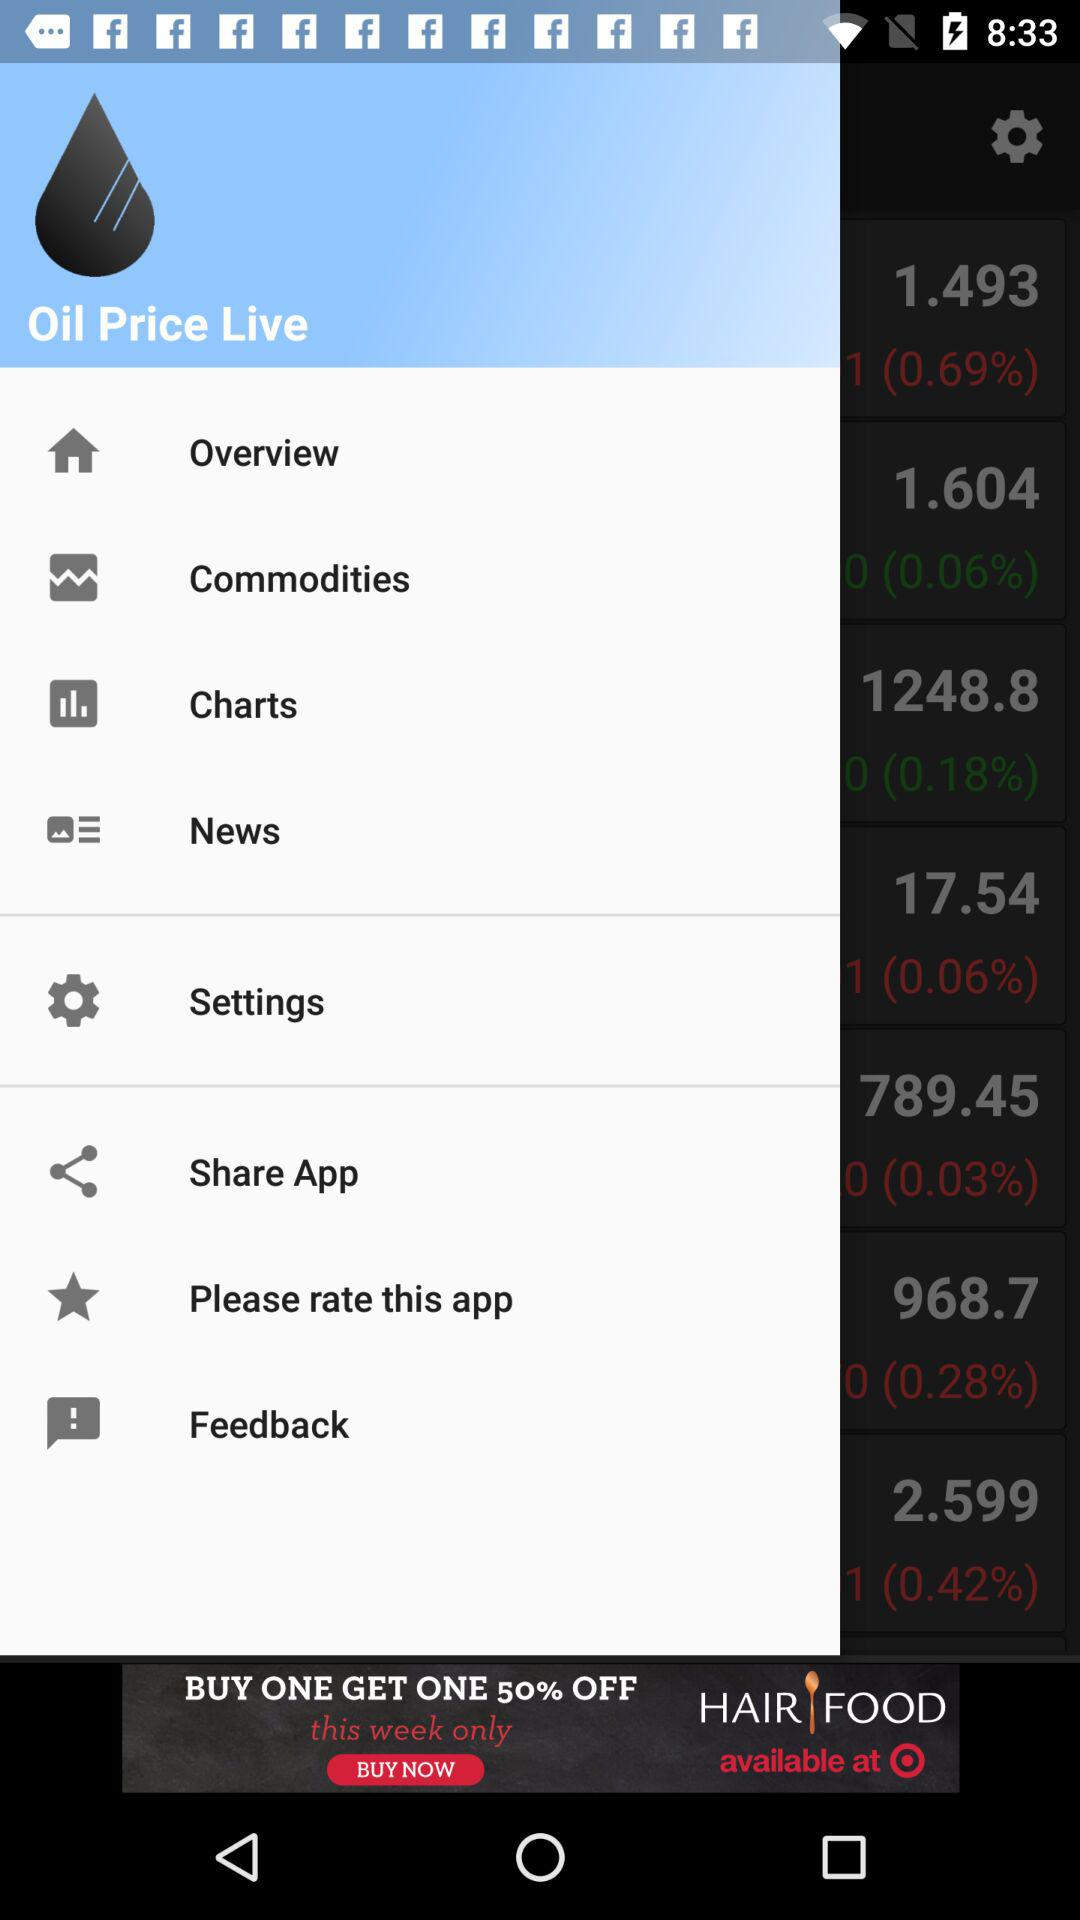What is the name of the application? The name of the application is "Oil Price Live". 